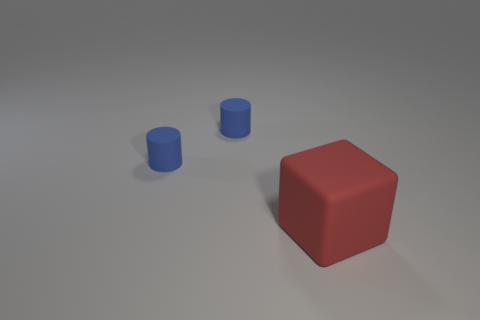Add 2 small yellow spheres. How many objects exist? 5 Subtract 1 cylinders. How many cylinders are left? 1 Subtract all gray cylinders. Subtract all yellow blocks. How many cylinders are left? 2 Subtract all cyan rubber cylinders. Subtract all matte cylinders. How many objects are left? 1 Add 1 cylinders. How many cylinders are left? 3 Add 3 blue objects. How many blue objects exist? 5 Subtract 0 green cubes. How many objects are left? 3 Subtract all blocks. How many objects are left? 2 